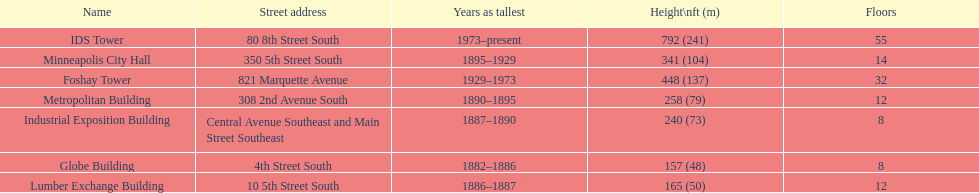Is the metropolitan building or the lumber exchange building taller? Metropolitan Building. 